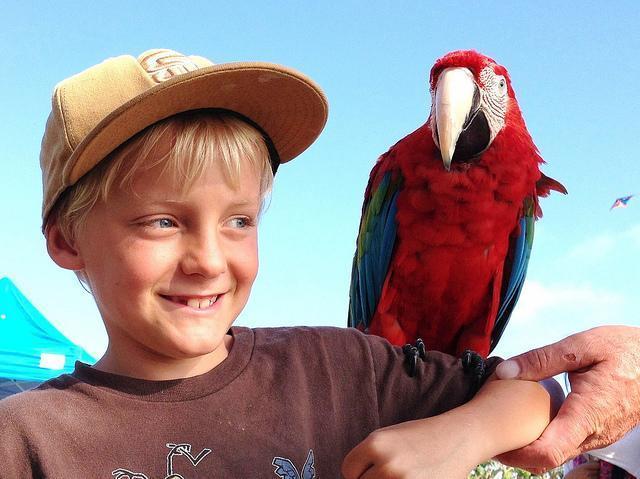How many birds can you see?
Give a very brief answer. 1. How many people are there?
Give a very brief answer. 2. 